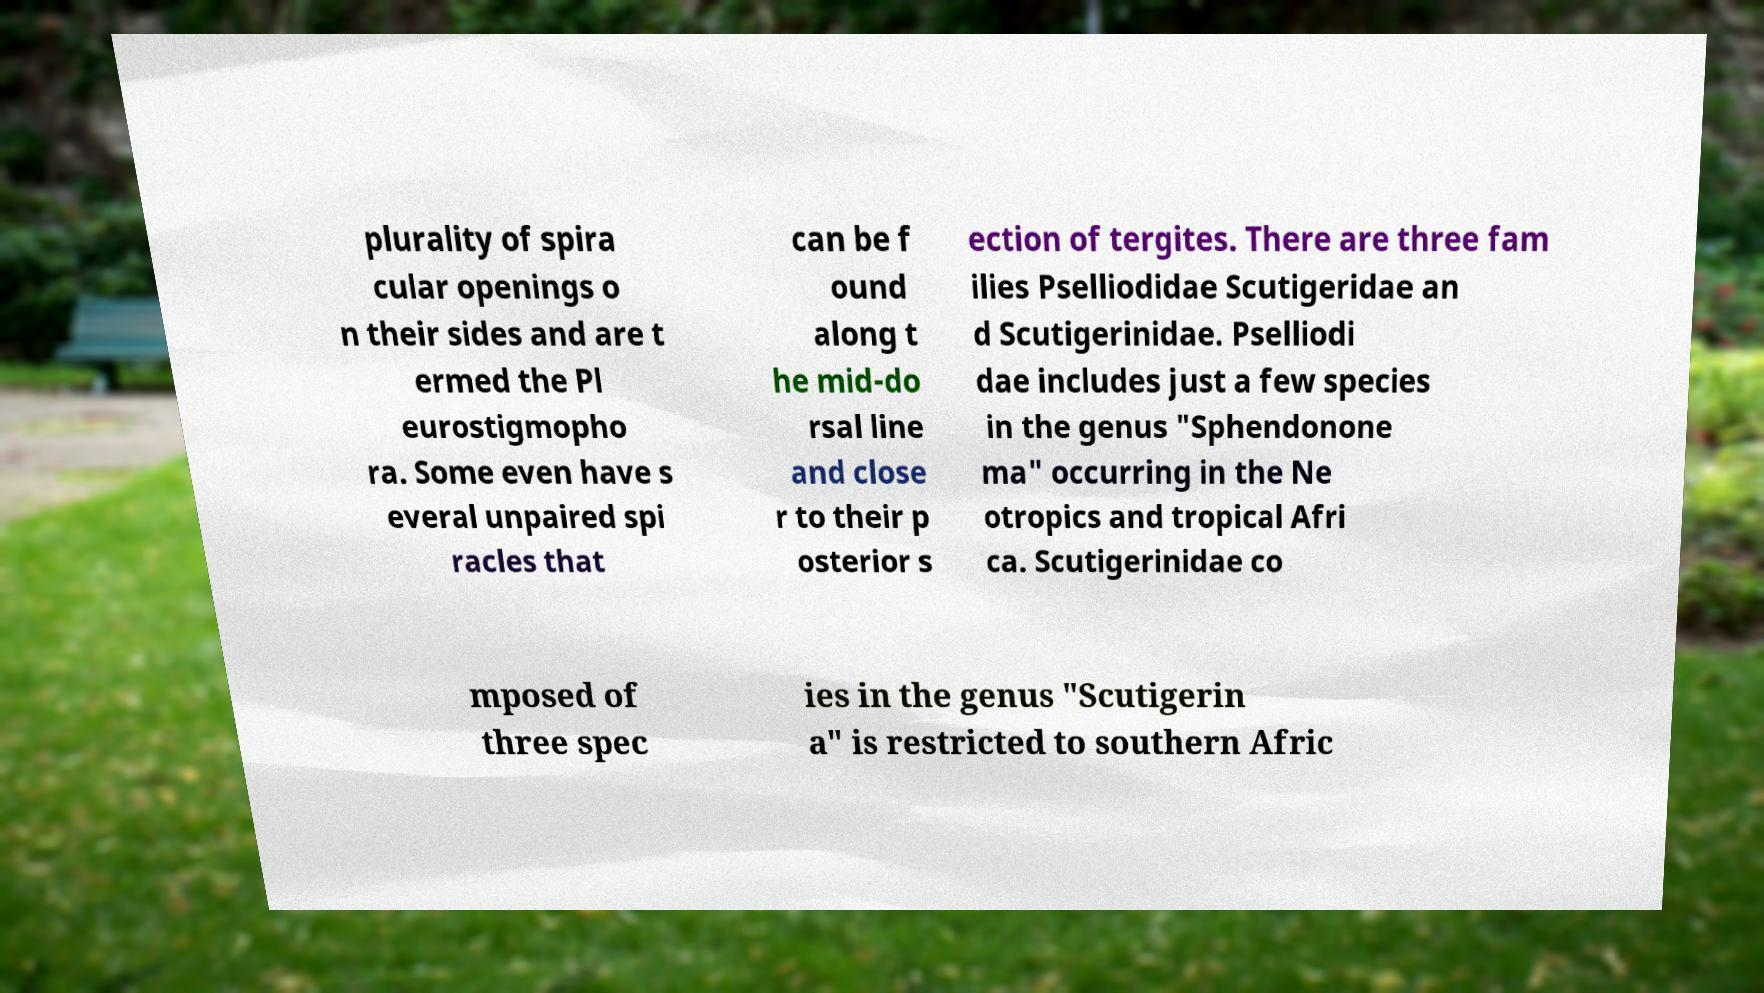For documentation purposes, I need the text within this image transcribed. Could you provide that? plurality of spira cular openings o n their sides and are t ermed the Pl eurostigmopho ra. Some even have s everal unpaired spi racles that can be f ound along t he mid-do rsal line and close r to their p osterior s ection of tergites. There are three fam ilies Pselliodidae Scutigeridae an d Scutigerinidae. Pselliodi dae includes just a few species in the genus "Sphendonone ma" occurring in the Ne otropics and tropical Afri ca. Scutigerinidae co mposed of three spec ies in the genus "Scutigerin a" is restricted to southern Afric 